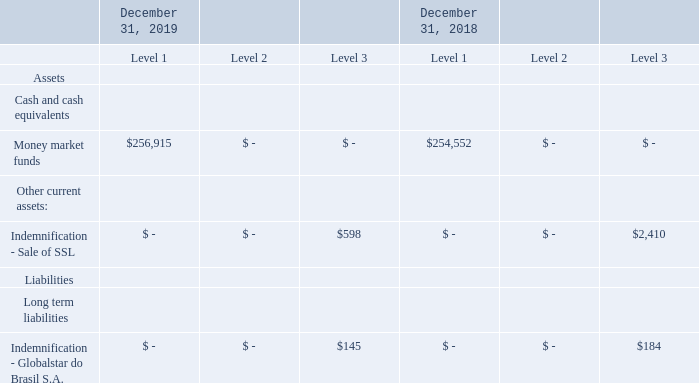Assets and Liabilities Measured at Fair Value
The following table presents our assets and liabilities measured at fair value on a recurring or non-recurring basis (in thousands):
The carrying amount of cash equivalents approximates fair value as of each reporting date because of the short maturity of those instruments.
The Company did not have any non-financial assets or non-financial liabilities that were recognized or disclosed at fair value as of December 31, 2019 and December 31, 2018.
What are the company's respective Level 3 fair value assets and liabilities in 2018?
Answer scale should be: thousand. $2,410, $184. What are the company's respective Level 3 fair value assets and liabilities in 2019?
Answer scale should be: thousand. $598, $145. What are the respective values of the Level 1 money market funds in 2018 and 2019 respectively?
Answer scale should be: thousand. $254,552, $256,915. What is the value of the company's net assets in 2019?
Answer scale should be: thousand. 256,915 + 598 - 145 
Answer: 257368. What is the value of the company's net assets in 2018?
Answer scale should be: thousand. 254,552 + 2,410 - 184 
Answer: 256778. What is the percentage change in the company's Level 3 liabilities between 2018 and 2019?
Answer scale should be: percent. (145 - 184)/184 
Answer: -21.2. 